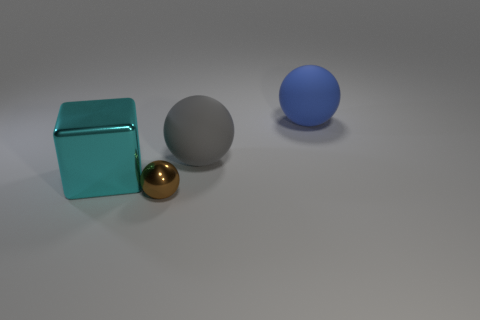Is the material of the gray thing the same as the large object behind the big gray matte object?
Your answer should be very brief. Yes. How many big rubber spheres have the same color as the big metallic object?
Your response must be concise. 0. How big is the brown object?
Your response must be concise. Small. Do the big blue rubber object and the shiny thing that is in front of the cyan cube have the same shape?
Your answer should be very brief. Yes. There is a ball that is the same material as the large gray object; what color is it?
Give a very brief answer. Blue. What is the size of the ball behind the large gray sphere?
Make the answer very short. Large. Is the number of small metal things right of the small brown object less than the number of big shiny blocks?
Give a very brief answer. Yes. Is there any other thing that is the same shape as the large cyan object?
Provide a short and direct response. No. Is the number of tiny purple metallic things less than the number of brown things?
Provide a short and direct response. Yes. There is a sphere that is in front of the large object to the left of the brown shiny thing; what is its color?
Make the answer very short. Brown. 